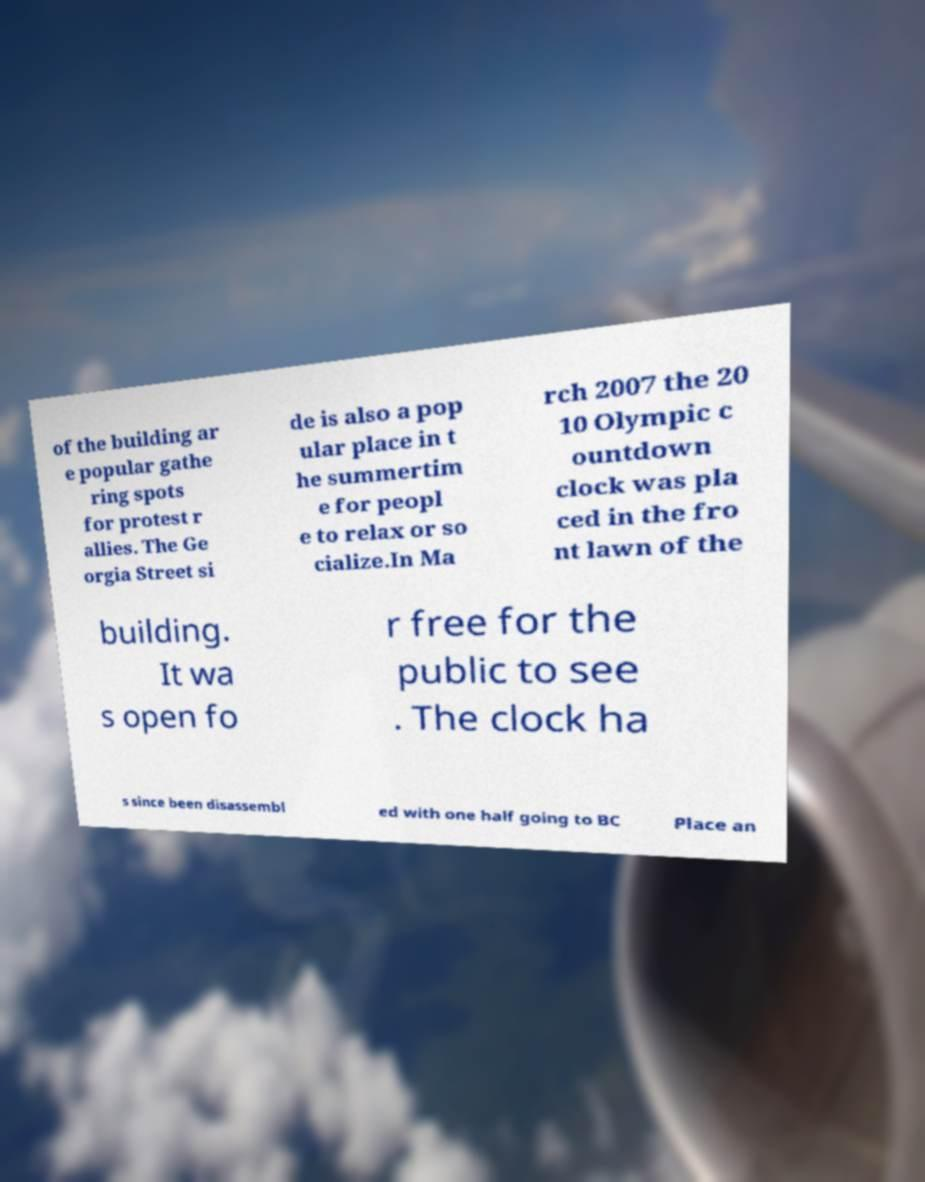Could you assist in decoding the text presented in this image and type it out clearly? of the building ar e popular gathe ring spots for protest r allies. The Ge orgia Street si de is also a pop ular place in t he summertim e for peopl e to relax or so cialize.In Ma rch 2007 the 20 10 Olympic c ountdown clock was pla ced in the fro nt lawn of the building. It wa s open fo r free for the public to see . The clock ha s since been disassembl ed with one half going to BC Place an 